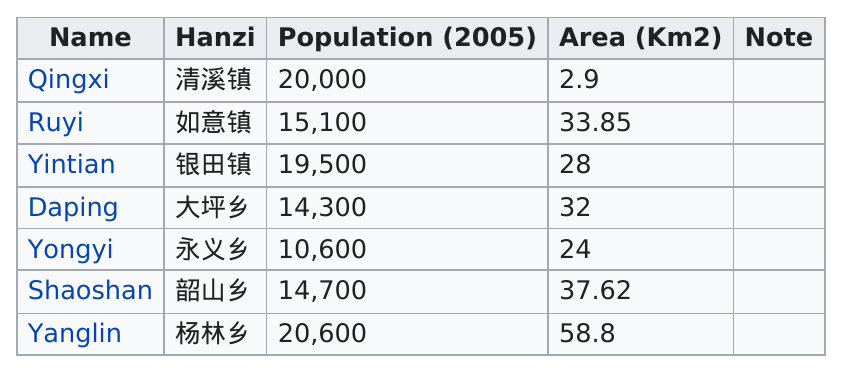Draw attention to some important aspects in this diagram. The Yanglin division has the most people out of all the divisions. It is incorrect to assume that the Yintian have more area than the Yanglin. The name "Yanglin" has the most area. Shaoshan has a larger area than Ruyi. The divisions with a population below 15,000 in 2005 were 3.. 